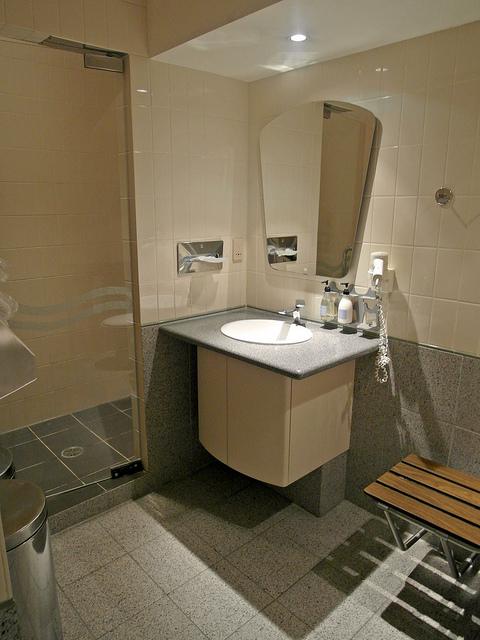What is above the sink?
Be succinct. Mirror. Is this a public restroom?
Give a very brief answer. Yes. Is this a hotel room?
Quick response, please. Yes. Is there a bathtub?
Write a very short answer. No. 